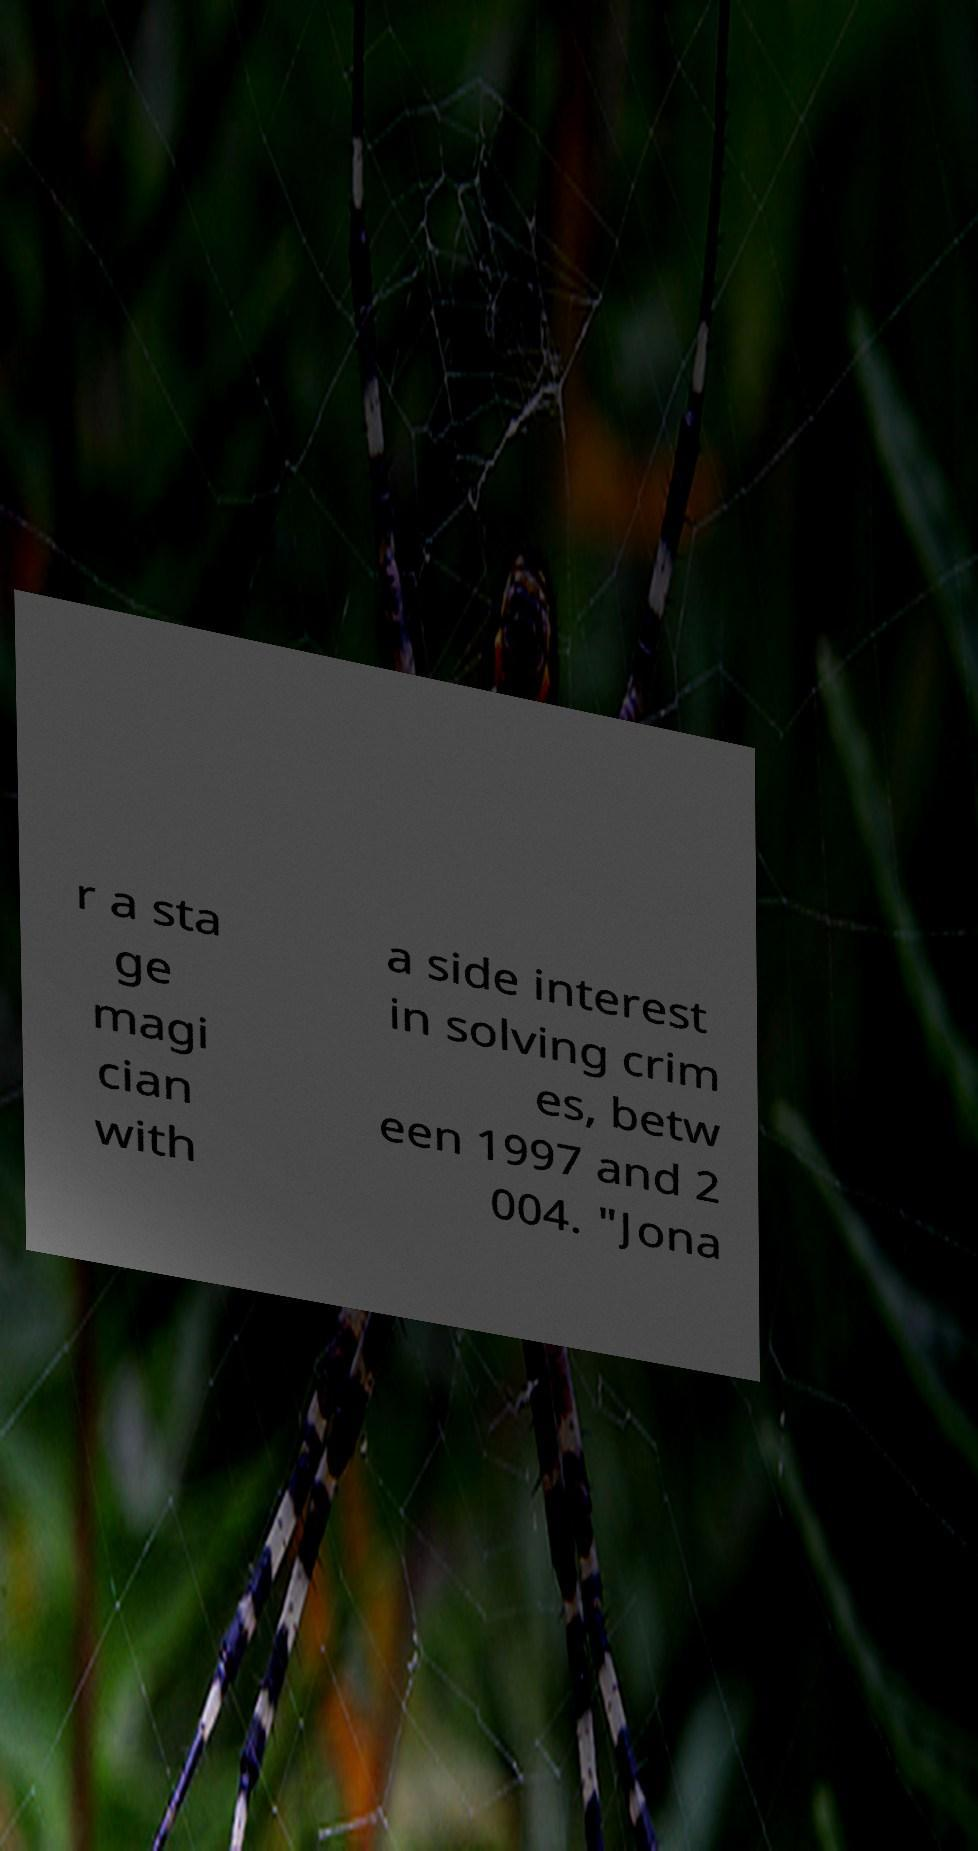What messages or text are displayed in this image? I need them in a readable, typed format. r a sta ge magi cian with a side interest in solving crim es, betw een 1997 and 2 004. "Jona 